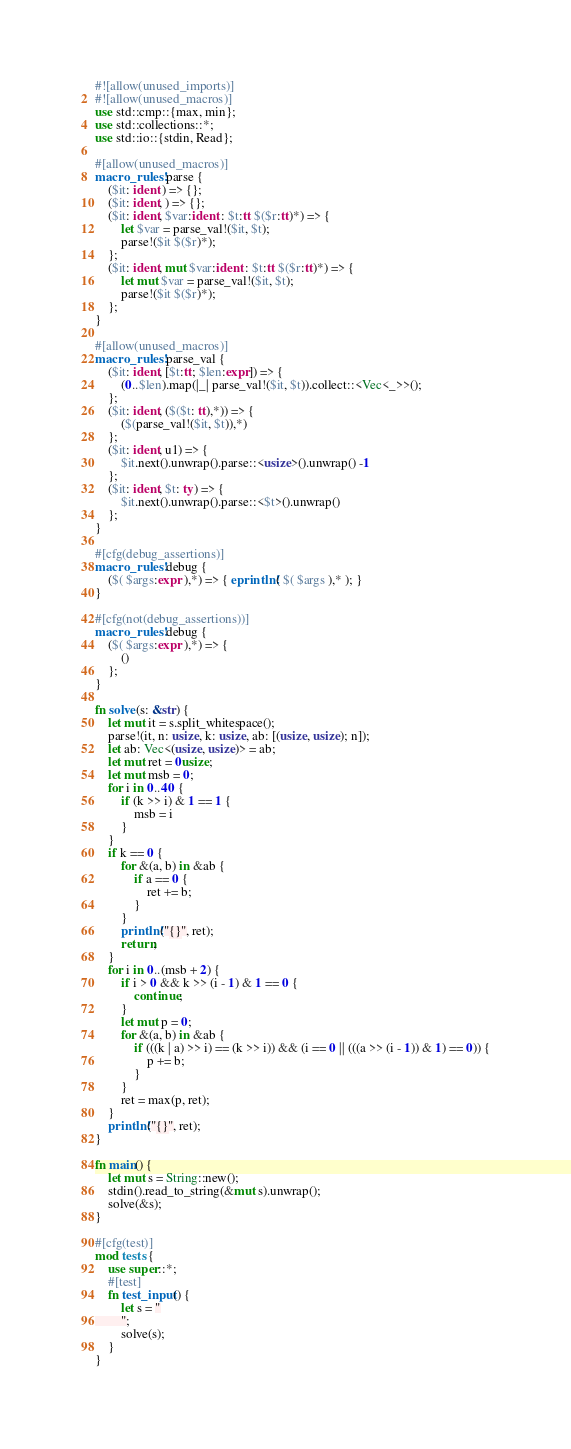<code> <loc_0><loc_0><loc_500><loc_500><_Rust_>#![allow(unused_imports)]
#![allow(unused_macros)]
use std::cmp::{max, min};
use std::collections::*;
use std::io::{stdin, Read};

#[allow(unused_macros)]
macro_rules! parse {
    ($it: ident ) => {};
    ($it: ident, ) => {};
    ($it: ident, $var:ident : $t:tt $($r:tt)*) => {
        let $var = parse_val!($it, $t);
        parse!($it $($r)*);
    };
    ($it: ident, mut $var:ident : $t:tt $($r:tt)*) => {
        let mut $var = parse_val!($it, $t);
        parse!($it $($r)*);
    };
}

#[allow(unused_macros)]
macro_rules! parse_val {
    ($it: ident, [$t:tt; $len:expr]) => {
        (0..$len).map(|_| parse_val!($it, $t)).collect::<Vec<_>>();
    };
    ($it: ident, ($($t: tt),*)) => {
        ($(parse_val!($it, $t)),*)
    };
    ($it: ident, u1) => {
        $it.next().unwrap().parse::<usize>().unwrap() -1
    };
    ($it: ident, $t: ty) => {
        $it.next().unwrap().parse::<$t>().unwrap()
    };
}

#[cfg(debug_assertions)]
macro_rules! debug {
    ($( $args:expr ),*) => { eprintln!( $( $args ),* ); }
}

#[cfg(not(debug_assertions))]
macro_rules! debug {
    ($( $args:expr ),*) => {
        ()
    };
}

fn solve(s: &str) {
    let mut it = s.split_whitespace();
    parse!(it, n: usize, k: usize, ab: [(usize, usize); n]);
    let ab: Vec<(usize, usize)> = ab;
    let mut ret = 0usize;
    let mut msb = 0;
    for i in 0..40 {
        if (k >> i) & 1 == 1 {
            msb = i
        }
    }
    if k == 0 {
        for &(a, b) in &ab {
            if a == 0 {
                ret += b;
            }
        }
        println!("{}", ret);
        return;
    }
    for i in 0..(msb + 2) {
        if i > 0 && k >> (i - 1) & 1 == 0 {
            continue;
        }
        let mut p = 0;
        for &(a, b) in &ab {
            if (((k | a) >> i) == (k >> i)) && (i == 0 || (((a >> (i - 1)) & 1) == 0)) {
                p += b;
            }
        }
        ret = max(p, ret);
    }
    println!("{}", ret);
}

fn main() {
    let mut s = String::new();
    stdin().read_to_string(&mut s).unwrap();
    solve(&s);
}

#[cfg(test)]
mod tests {
    use super::*;
    #[test]
    fn test_input() {
        let s = "
        ";
        solve(s);
    }
}
</code> 